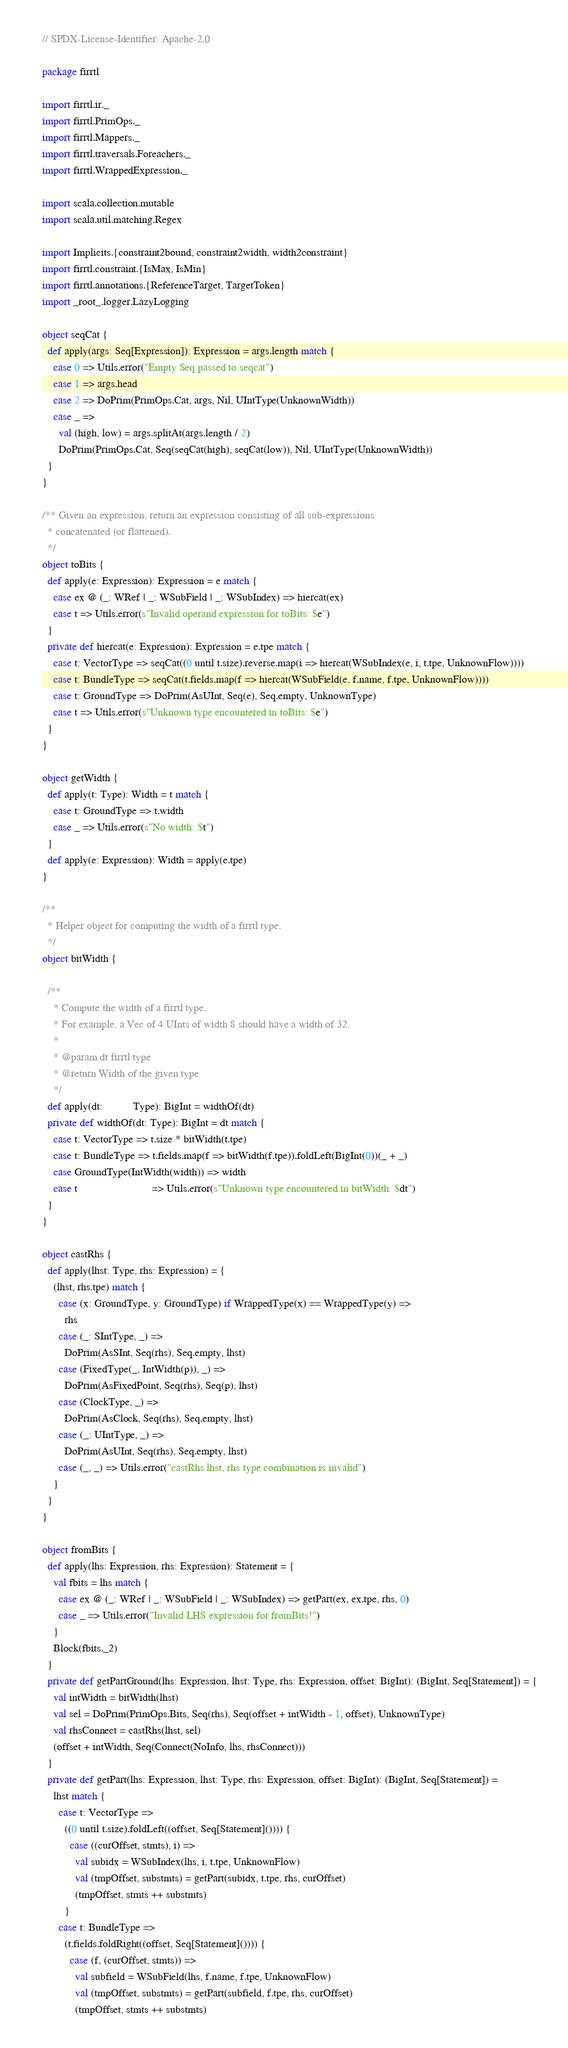<code> <loc_0><loc_0><loc_500><loc_500><_Scala_>// SPDX-License-Identifier: Apache-2.0

package firrtl

import firrtl.ir._
import firrtl.PrimOps._
import firrtl.Mappers._
import firrtl.traversals.Foreachers._
import firrtl.WrappedExpression._

import scala.collection.mutable
import scala.util.matching.Regex

import Implicits.{constraint2bound, constraint2width, width2constraint}
import firrtl.constraint.{IsMax, IsMin}
import firrtl.annotations.{ReferenceTarget, TargetToken}
import _root_.logger.LazyLogging

object seqCat {
  def apply(args: Seq[Expression]): Expression = args.length match {
    case 0 => Utils.error("Empty Seq passed to seqcat")
    case 1 => args.head
    case 2 => DoPrim(PrimOps.Cat, args, Nil, UIntType(UnknownWidth))
    case _ =>
      val (high, low) = args.splitAt(args.length / 2)
      DoPrim(PrimOps.Cat, Seq(seqCat(high), seqCat(low)), Nil, UIntType(UnknownWidth))
  }
}

/** Given an expression, return an expression consisting of all sub-expressions
  * concatenated (or flattened).
  */
object toBits {
  def apply(e: Expression): Expression = e match {
    case ex @ (_: WRef | _: WSubField | _: WSubIndex) => hiercat(ex)
    case t => Utils.error(s"Invalid operand expression for toBits: $e")
  }
  private def hiercat(e: Expression): Expression = e.tpe match {
    case t: VectorType => seqCat((0 until t.size).reverse.map(i => hiercat(WSubIndex(e, i, t.tpe, UnknownFlow))))
    case t: BundleType => seqCat(t.fields.map(f => hiercat(WSubField(e, f.name, f.tpe, UnknownFlow))))
    case t: GroundType => DoPrim(AsUInt, Seq(e), Seq.empty, UnknownType)
    case t => Utils.error(s"Unknown type encountered in toBits: $e")
  }
}

object getWidth {
  def apply(t: Type): Width = t match {
    case t: GroundType => t.width
    case _ => Utils.error(s"No width: $t")
  }
  def apply(e: Expression): Width = apply(e.tpe)
}

/**
  * Helper object for computing the width of a firrtl type.
  */
object bitWidth {

  /**
    * Compute the width of a firrtl type.
    * For example, a Vec of 4 UInts of width 8 should have a width of 32.
    *
    * @param dt firrtl type
    * @return Width of the given type
    */
  def apply(dt:           Type): BigInt = widthOf(dt)
  private def widthOf(dt: Type): BigInt = dt match {
    case t: VectorType => t.size * bitWidth(t.tpe)
    case t: BundleType => t.fields.map(f => bitWidth(f.tpe)).foldLeft(BigInt(0))(_ + _)
    case GroundType(IntWidth(width)) => width
    case t                           => Utils.error(s"Unknown type encountered in bitWidth: $dt")
  }
}

object castRhs {
  def apply(lhst: Type, rhs: Expression) = {
    (lhst, rhs.tpe) match {
      case (x: GroundType, y: GroundType) if WrappedType(x) == WrappedType(y) =>
        rhs
      case (_: SIntType, _) =>
        DoPrim(AsSInt, Seq(rhs), Seq.empty, lhst)
      case (FixedType(_, IntWidth(p)), _) =>
        DoPrim(AsFixedPoint, Seq(rhs), Seq(p), lhst)
      case (ClockType, _) =>
        DoPrim(AsClock, Seq(rhs), Seq.empty, lhst)
      case (_: UIntType, _) =>
        DoPrim(AsUInt, Seq(rhs), Seq.empty, lhst)
      case (_, _) => Utils.error("castRhs lhst, rhs type combination is invalid")
    }
  }
}

object fromBits {
  def apply(lhs: Expression, rhs: Expression): Statement = {
    val fbits = lhs match {
      case ex @ (_: WRef | _: WSubField | _: WSubIndex) => getPart(ex, ex.tpe, rhs, 0)
      case _ => Utils.error("Invalid LHS expression for fromBits!")
    }
    Block(fbits._2)
  }
  private def getPartGround(lhs: Expression, lhst: Type, rhs: Expression, offset: BigInt): (BigInt, Seq[Statement]) = {
    val intWidth = bitWidth(lhst)
    val sel = DoPrim(PrimOps.Bits, Seq(rhs), Seq(offset + intWidth - 1, offset), UnknownType)
    val rhsConnect = castRhs(lhst, sel)
    (offset + intWidth, Seq(Connect(NoInfo, lhs, rhsConnect)))
  }
  private def getPart(lhs: Expression, lhst: Type, rhs: Expression, offset: BigInt): (BigInt, Seq[Statement]) =
    lhst match {
      case t: VectorType =>
        ((0 until t.size).foldLeft((offset, Seq[Statement]()))) {
          case ((curOffset, stmts), i) =>
            val subidx = WSubIndex(lhs, i, t.tpe, UnknownFlow)
            val (tmpOffset, substmts) = getPart(subidx, t.tpe, rhs, curOffset)
            (tmpOffset, stmts ++ substmts)
        }
      case t: BundleType =>
        (t.fields.foldRight((offset, Seq[Statement]()))) {
          case (f, (curOffset, stmts)) =>
            val subfield = WSubField(lhs, f.name, f.tpe, UnknownFlow)
            val (tmpOffset, substmts) = getPart(subfield, f.tpe, rhs, curOffset)
            (tmpOffset, stmts ++ substmts)</code> 